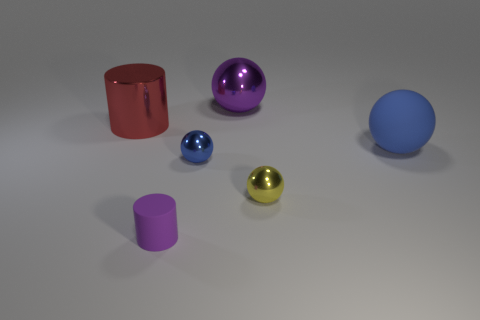There is a small matte thing that is the same color as the large metallic sphere; what is its shape?
Offer a very short reply. Cylinder. What number of yellow things are either tiny cylinders or metallic cylinders?
Your response must be concise. 0. Are there any purple shiny spheres left of the tiny blue shiny object?
Keep it short and to the point. No. Does the big object in front of the red object have the same shape as the red metallic object that is on the left side of the big purple metal ball?
Provide a short and direct response. No. What is the material of the yellow object that is the same shape as the blue matte thing?
Ensure brevity in your answer.  Metal. How many blocks are yellow metallic things or tiny purple objects?
Give a very brief answer. 0. How many cylinders are made of the same material as the small yellow object?
Offer a very short reply. 1. Are the tiny sphere left of the purple shiny ball and the purple object on the right side of the small blue sphere made of the same material?
Your answer should be very brief. Yes. There is a tiny metallic object that is to the left of the large purple metal thing that is on the left side of the yellow metallic thing; what number of big metal objects are to the right of it?
Make the answer very short. 1. There is a thing on the right side of the tiny yellow sphere; does it have the same color as the cylinder that is to the right of the red cylinder?
Make the answer very short. No. 